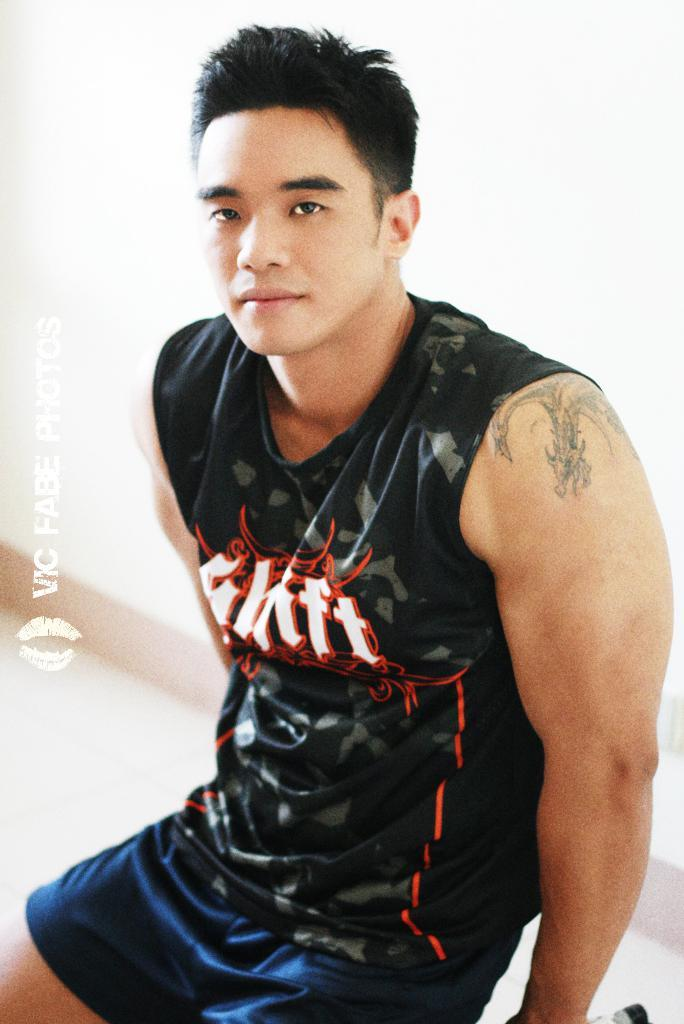<image>
Provide a brief description of the given image. The photography company that took the picture is Vic Fabe Photos 